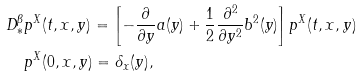<formula> <loc_0><loc_0><loc_500><loc_500>D _ { * } ^ { \beta } & p ^ { X } ( t , x , y ) = \left [ - \frac { \partial } { \partial y } a ( y ) + \frac { 1 } { 2 } \frac { \partial ^ { 2 } } { \partial y ^ { 2 } } b ^ { 2 } ( y ) \right ] p ^ { X } ( t , x , y ) \\ & p ^ { X } ( 0 , x , y ) = \delta _ { x } ( y ) ,</formula> 